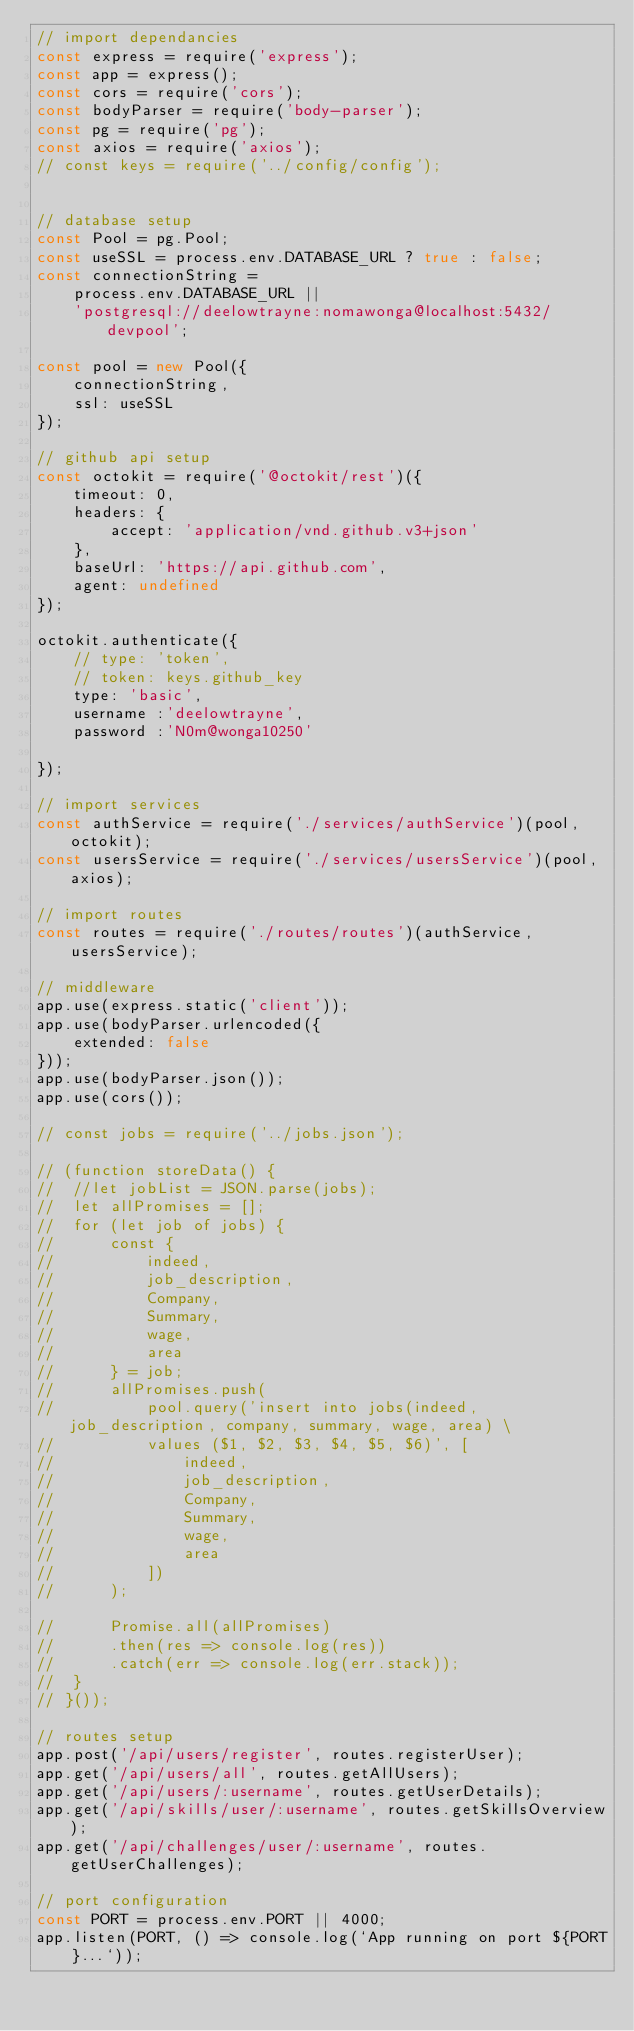Convert code to text. <code><loc_0><loc_0><loc_500><loc_500><_JavaScript_>// import dependancies
const express = require('express');
const app = express();
const cors = require('cors');
const bodyParser = require('body-parser');
const pg = require('pg');
const axios = require('axios');
// const keys = require('../config/config');


// database setup
const Pool = pg.Pool;
const useSSL = process.env.DATABASE_URL ? true : false;
const connectionString =
	process.env.DATABASE_URL ||
	'postgresql://deelowtrayne:nomawonga@localhost:5432/devpool';

const pool = new Pool({
	connectionString,
	ssl: useSSL
});

// github api setup
const octokit = require('@octokit/rest')({
	timeout: 0,
	headers: {
		accept: 'application/vnd.github.v3+json'
	},
	baseUrl: 'https://api.github.com',
	agent: undefined
});

octokit.authenticate({
	// type: 'token',
	// token: keys.github_key
	type: 'basic',
	username :'deelowtrayne',
	password :'N0m@wonga10250'

});

// import services
const authService = require('./services/authService')(pool, octokit);
const usersService = require('./services/usersService')(pool, axios);

// import routes
const routes = require('./routes/routes')(authService, usersService);

// middleware
app.use(express.static('client'));
app.use(bodyParser.urlencoded({
	extended: false
}));
app.use(bodyParser.json());
app.use(cors());

// const jobs = require('../jobs.json');

// (function storeData() {
// 	//let jobList = JSON.parse(jobs);
// 	let allPromises = [];
// 	for (let job of jobs) {
// 		const {
// 			indeed,
// 			job_description,
// 			Company,
// 			Summary,
// 			wage,
// 			area
// 		} = job;
// 		allPromises.push(
// 			pool.query('insert into jobs(indeed, job_description, company, summary, wage, area) \
// 			values ($1, $2, $3, $4, $5, $6)', [
// 				indeed,
// 				job_description,
// 				Company,
// 				Summary,
// 				wage,
// 				area
// 			])
// 		);

// 		Promise.all(allPromises)
// 		.then(res => console.log(res))
// 		.catch(err => console.log(err.stack));
// 	}
// }());

// routes setup
app.post('/api/users/register', routes.registerUser);
app.get('/api/users/all', routes.getAllUsers);
app.get('/api/users/:username', routes.getUserDetails);
app.get('/api/skills/user/:username', routes.getSkillsOverview);
app.get('/api/challenges/user/:username', routes.getUserChallenges);

// port configuration
const PORT = process.env.PORT || 4000;
app.listen(PORT, () => console.log(`App running on port ${PORT}...`));
</code> 